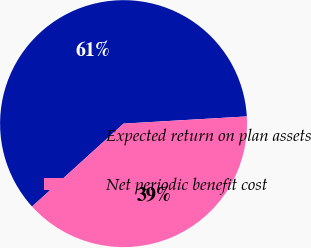<chart> <loc_0><loc_0><loc_500><loc_500><pie_chart><fcel>Expected return on plan assets<fcel>Net periodic benefit cost<nl><fcel>60.79%<fcel>39.21%<nl></chart> 